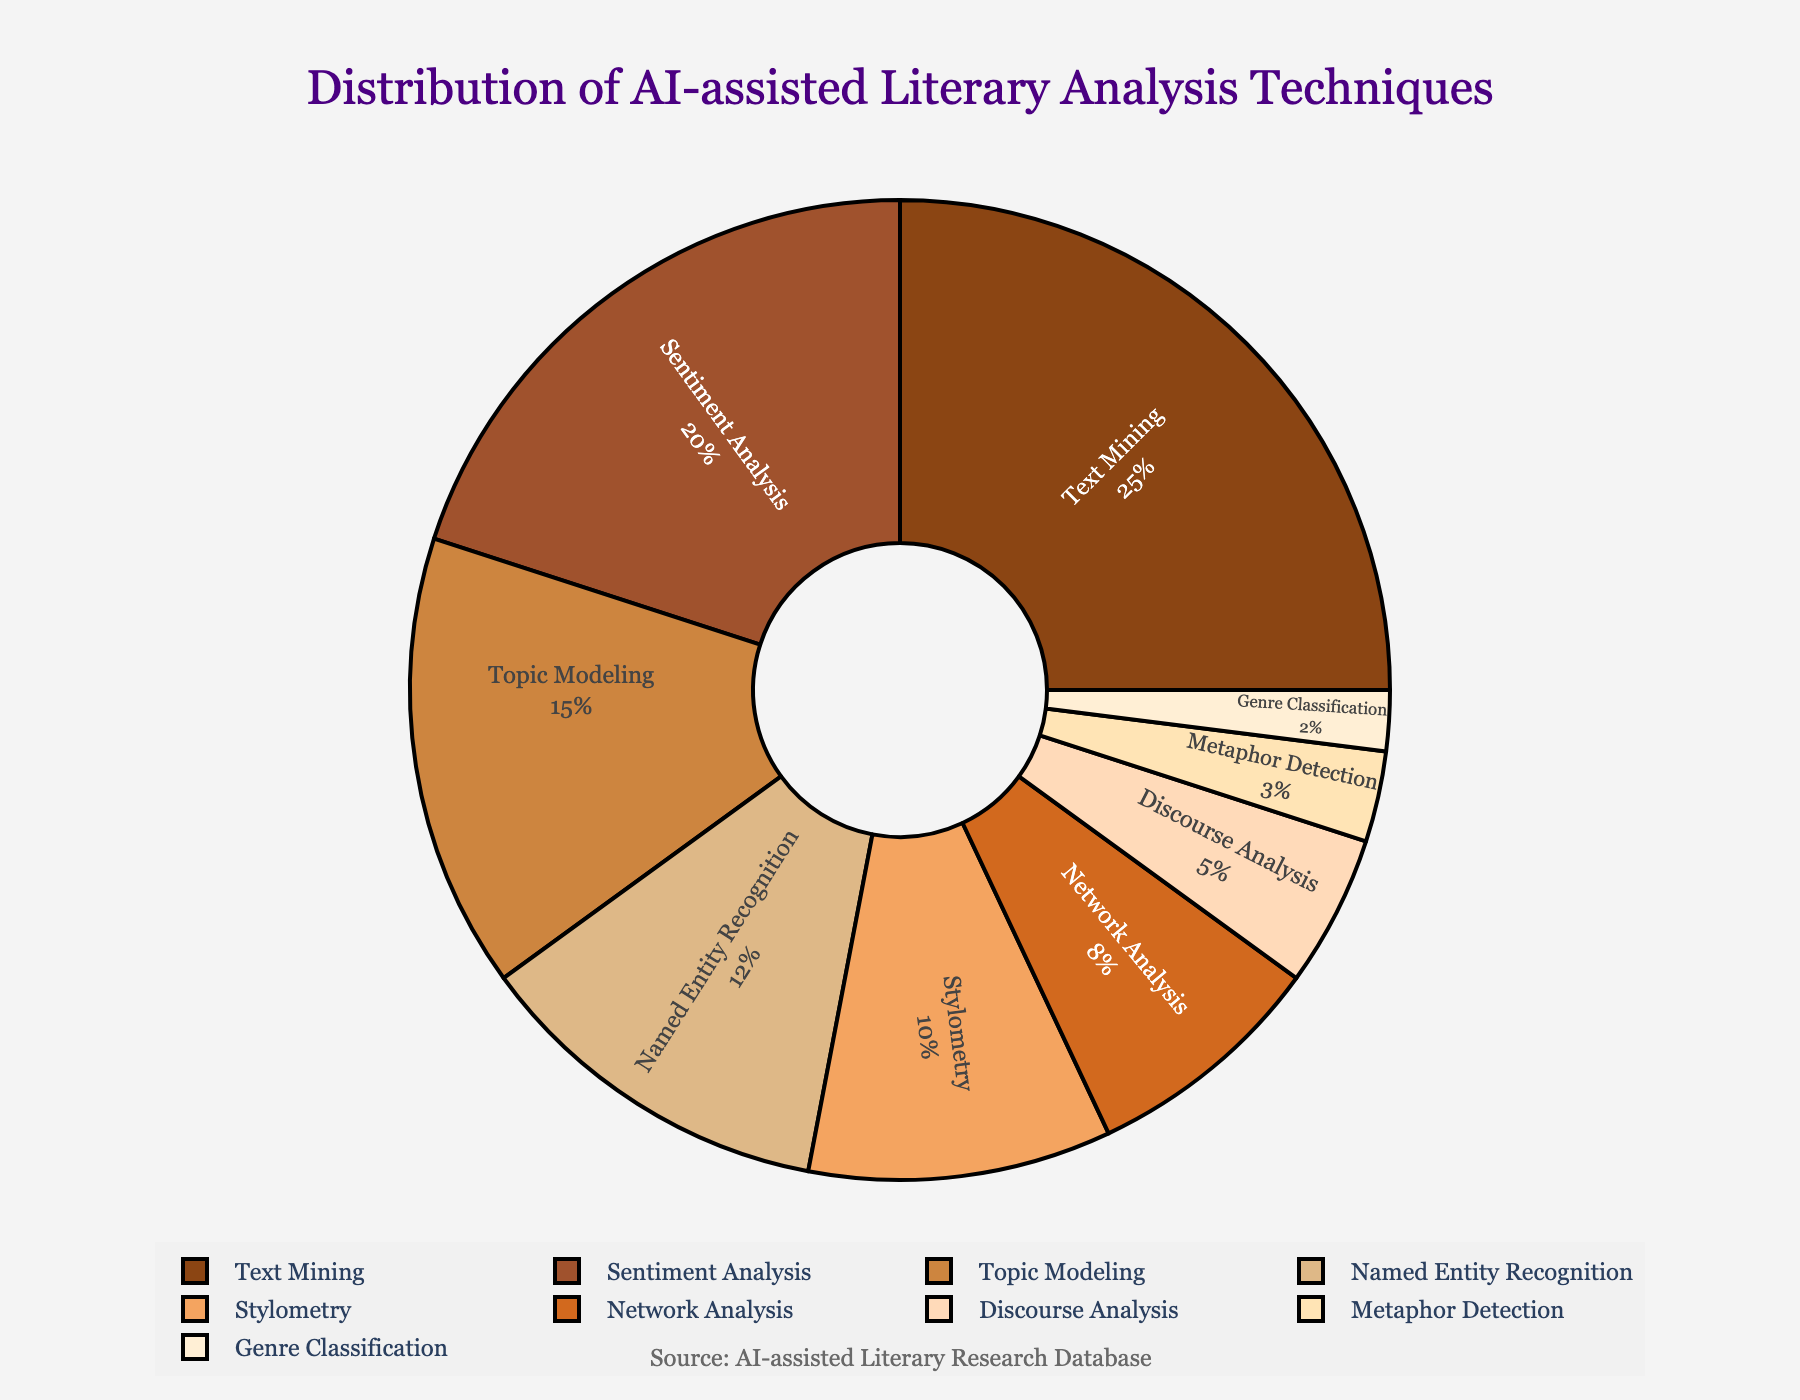What is the most common AI-assisted literary analysis technique in research papers? The pie chart shows the distribution of different AI-assisted literary analysis techniques. From the chart, Text Mining has the highest percentage at 25%.
Answer: Text Mining Which AI-assisted techniques collectively contribute to more than half of the research methods? Summing percentages directly from the chart: Text Mining (25%) + Sentiment Analysis (20%) + Topic Modeling (15%) = 60%. Thus, these three techniques together account for more than 50%.
Answer: Text Mining, Sentiment Analysis, and Topic Modeling Which technique is more popular: Named Entity Recognition or Network Analysis? Comparing the percentages in the pie chart, Named Entity Recognition has 12%, while Network Analysis has 8%. Since 12% is greater than 8%, Named Entity Recognition is more popular.
Answer: Named Entity Recognition How much more popular is Named Entity Recognition compared to Genre Classification? The percentages for Named Entity Recognition and Genre Classification are 12% and 2%, respectively. Subtracting these, 12% - 2% = 10%, making Named Entity Recognition 10% more popular.
Answer: 10% Which technique has the lowest percentage, and what is that percentage? From the pie chart, Genre Classification has the smallest slice, accounting for 2% of the methods used.
Answer: Genre Classification, 2% What is the combined percentage of Stylometry and Network Analysis? According to the pie chart, Stylometry is 10% and Network Analysis is 8%. Adding these together: 10% + 8% = 18%.
Answer: 18% How do Text Mining and Sentiment Analysis compare? Text Mining has a percentage of 25%, whereas Sentiment Analysis has 20%. Since 25% is greater than 20%, Text Mining is more prevalent.
Answer: Text Mining Which color represents Discourse Analysis in the pie chart? The pie chart's color palette follows a sequence, and Discourse Analysis is represented by a particular color. It is shown in a darker shade within the chart.
Answer: Dark brown How does the popularity of Metaphor Detection compare to Genre Classification? Metaphor Detection represents 3% and Genre Classification 2%. Since 3% is greater than 2%, Metaphor Detection is slightly more popular.
Answer: Metaphor Detection If you combine the percentages of the three least common techniques, what is their total share? The three least common techniques are Genre Classification (2%), Metaphor Detection (3%), and Discourse Analysis (5%). Adding these gives 2% + 3% + 5% = 10%.
Answer: 10% 